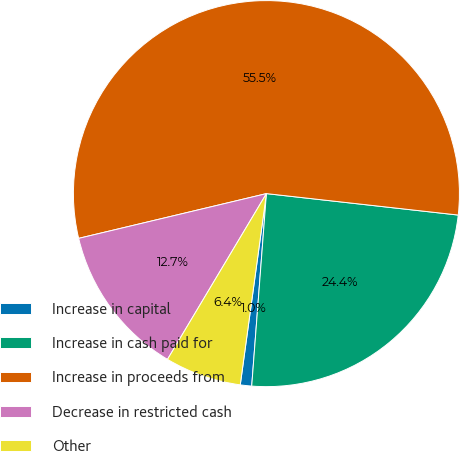Convert chart. <chart><loc_0><loc_0><loc_500><loc_500><pie_chart><fcel>Increase in capital<fcel>Increase in cash paid for<fcel>Increase in proceeds from<fcel>Decrease in restricted cash<fcel>Other<nl><fcel>0.95%<fcel>24.44%<fcel>55.49%<fcel>12.71%<fcel>6.4%<nl></chart> 